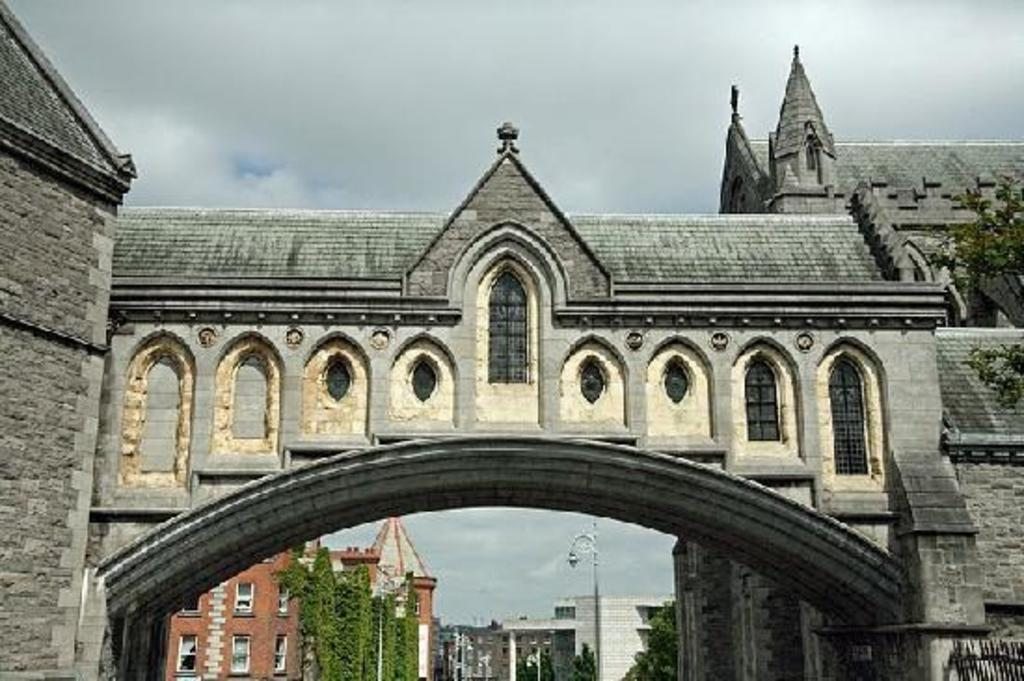What type of structure is the main subject of the image? There is a fort in the image. What can be seen at the bottom of the image? There are trees and buildings at the bottom of the image. What is the condition of the sky in the image? The sky is cloudy at the top of the image. What type of property is being sold in the image? There is no indication of a property being sold in the image; it primarily features a fort and its surroundings. 